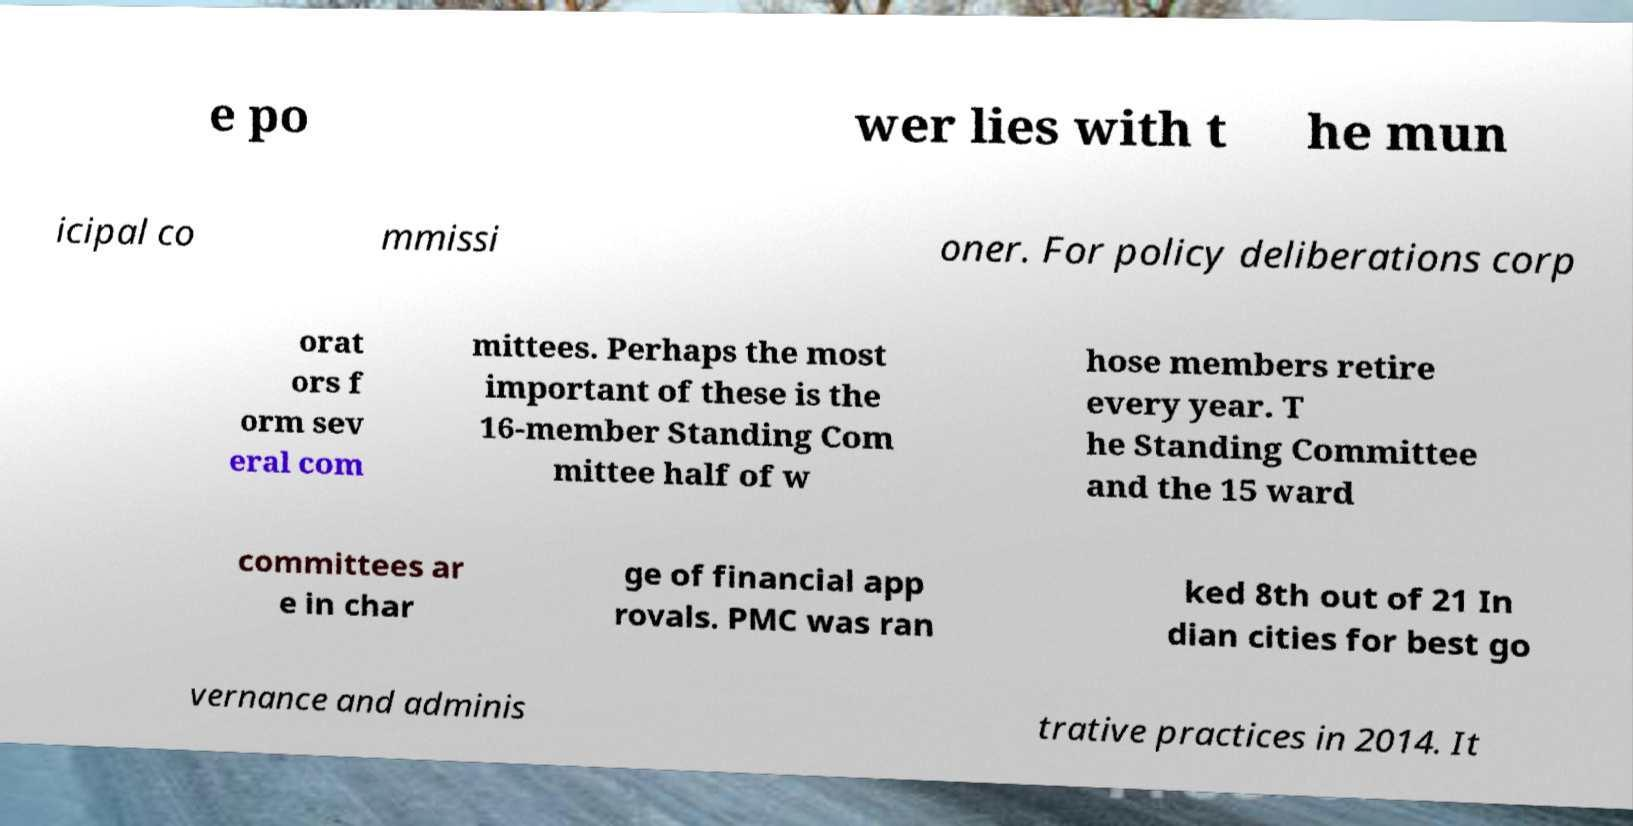Can you read and provide the text displayed in the image?This photo seems to have some interesting text. Can you extract and type it out for me? e po wer lies with t he mun icipal co mmissi oner. For policy deliberations corp orat ors f orm sev eral com mittees. Perhaps the most important of these is the 16-member Standing Com mittee half of w hose members retire every year. T he Standing Committee and the 15 ward committees ar e in char ge of financial app rovals. PMC was ran ked 8th out of 21 In dian cities for best go vernance and adminis trative practices in 2014. It 